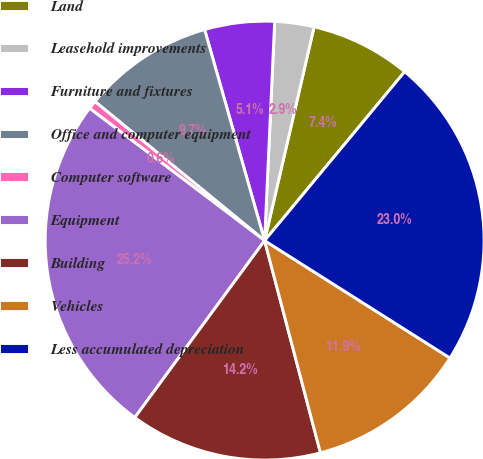Convert chart. <chart><loc_0><loc_0><loc_500><loc_500><pie_chart><fcel>Land<fcel>Leasehold improvements<fcel>Furniture and fixtures<fcel>Office and computer equipment<fcel>Computer software<fcel>Equipment<fcel>Building<fcel>Vehicles<fcel>Less accumulated depreciation<nl><fcel>7.4%<fcel>2.89%<fcel>5.14%<fcel>9.66%<fcel>0.63%<fcel>25.23%<fcel>14.17%<fcel>11.92%<fcel>22.97%<nl></chart> 